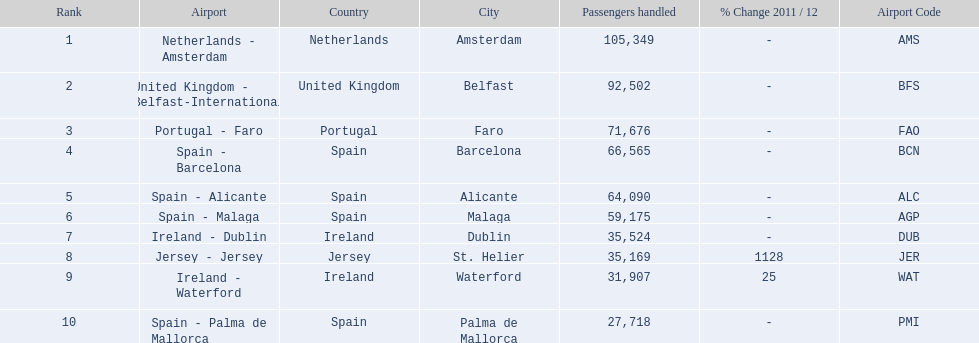How many airports in spain are among the 10 busiest routes to and from london southend airport in 2012? 4. 